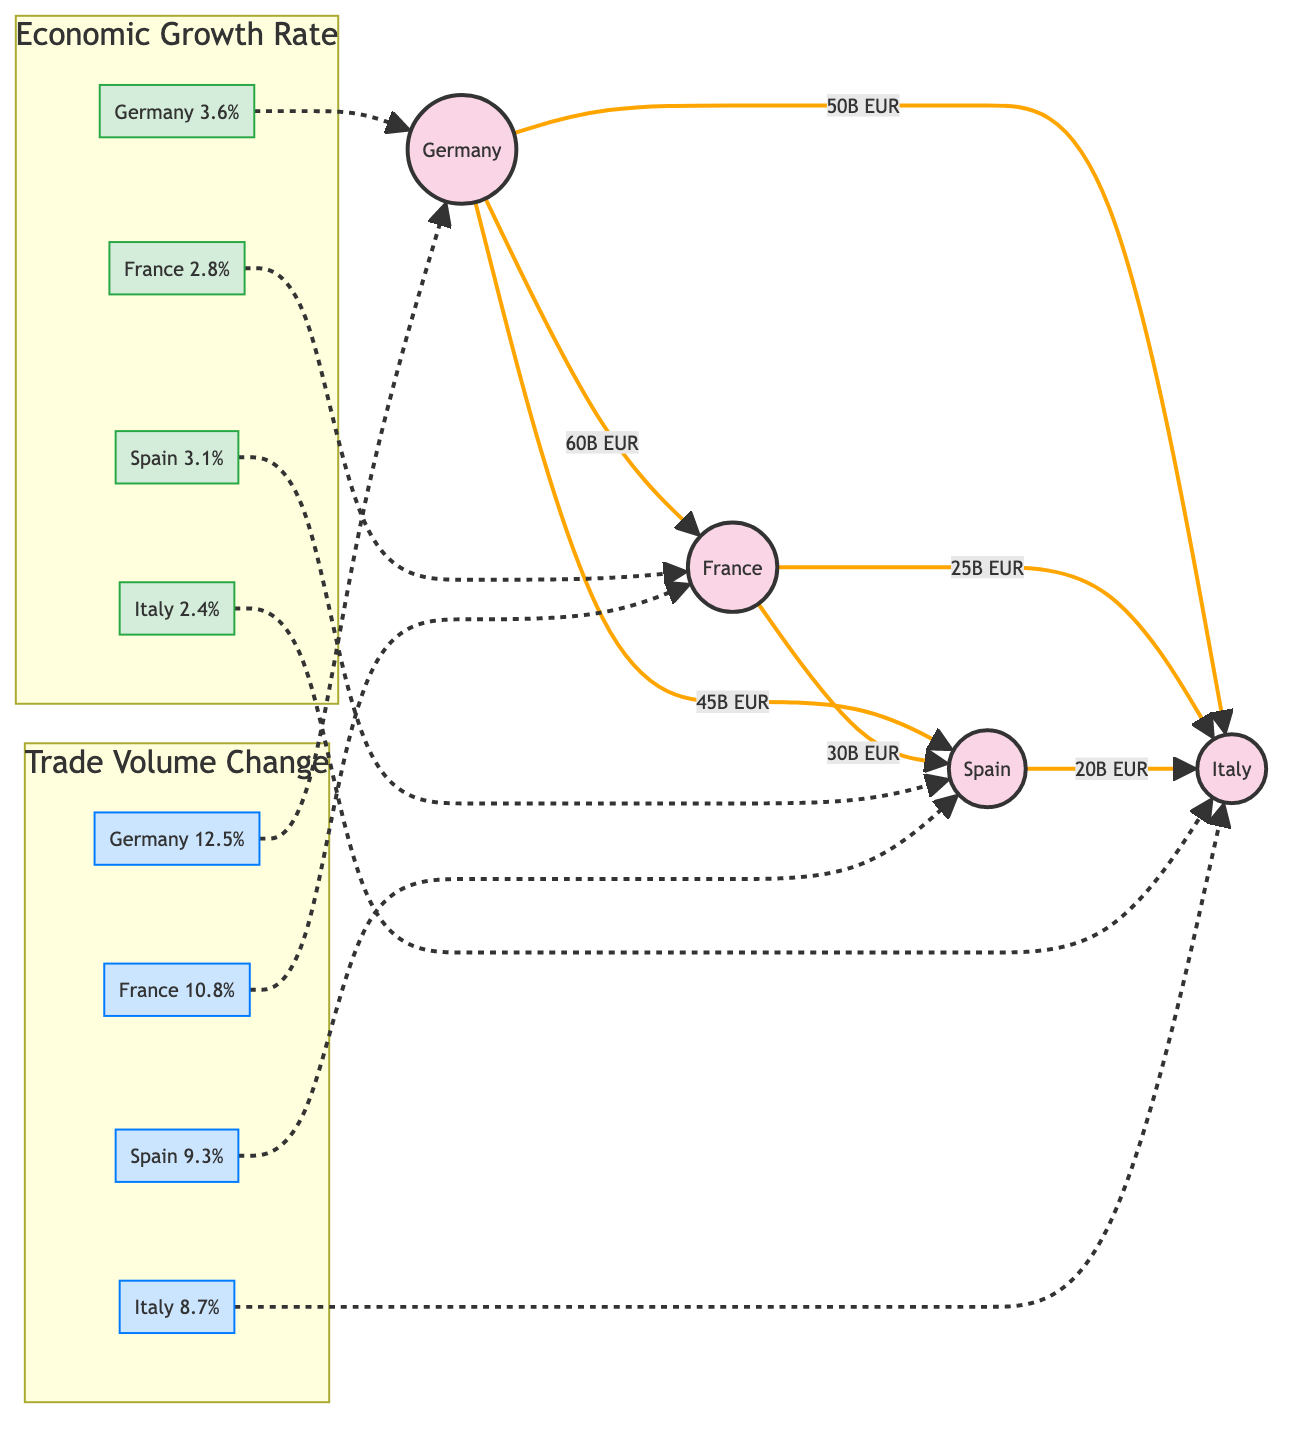What is the economic growth rate for Germany? The diagram indicates that Germany's economic growth rate is specified as 3.6%. This is directly listed within the Economic Growth Rate section of the flowchart.
Answer: 3.6% Which country has the highest trade volume change? By examining the Trade Volume Change section of the diagram, Germany shows an increase of 12.5%, which is greater than the percentages for France, Spain, and Italy.
Answer: Germany What is the trade volume from Germany to France? The diagram details a trade volume of 60 billion euros from Germany to France, represented by the arrow connecting these two nodes in the flowchart.
Answer: 60B EUR How many trade connections are shown in the diagram? Counting all the arrows connecting countries in the diagram reveals that there are a total of six trade relationships represented—one from Germany to France, two from Germany to Spain and Italy, one from France to Spain and Italy, and one from Spain to Italy.
Answer: 6 What is the economic growth rate difference between Spain and Italy? Spain's growth rate is 3.1% and Italy's is 2.4%. Subtracting the latter from the former gives a difference of 0.7%.
Answer: 0.7% How much trade volume change does France experience? Upon reviewing the Trade Volume Change section, France has a trade volume change of 10.8%. This value is clearly marked in the respective section of the flowchart.
Answer: 10.8% Which country benefits from the most significant trade volume with Germany after France? The diagram indicates that Germany's trade volume with Spain is 45 billion euros, which is higher than its trade volumes with Italy (50 billion euros) and France (60 billion euros). Therefore, Spain has the second-highest trade volume from Germany.
Answer: Spain What percentage of trade volume change does Italy exhibit? According to the Trade Volume Change section of the diagram, Italy shows a change of 8.7%. This is explicitly stated next to the Italian node in the flowchart.
Answer: 8.7% 